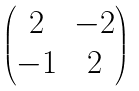Convert formula to latex. <formula><loc_0><loc_0><loc_500><loc_500>\begin{pmatrix} 2 & - 2 \\ - 1 & 2 \end{pmatrix}</formula> 